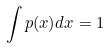<formula> <loc_0><loc_0><loc_500><loc_500>\int p ( x ) d x = 1</formula> 